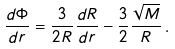Convert formula to latex. <formula><loc_0><loc_0><loc_500><loc_500>\frac { d \Phi } { d r } = \frac { 3 } { 2 R } \frac { d R } { d r } - \frac { 3 } { 2 } \frac { \sqrt { M } } { R } \, .</formula> 